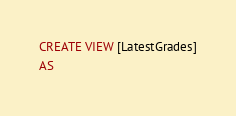<code> <loc_0><loc_0><loc_500><loc_500><_SQL_>CREATE VIEW [LatestGrades]
AS</code> 